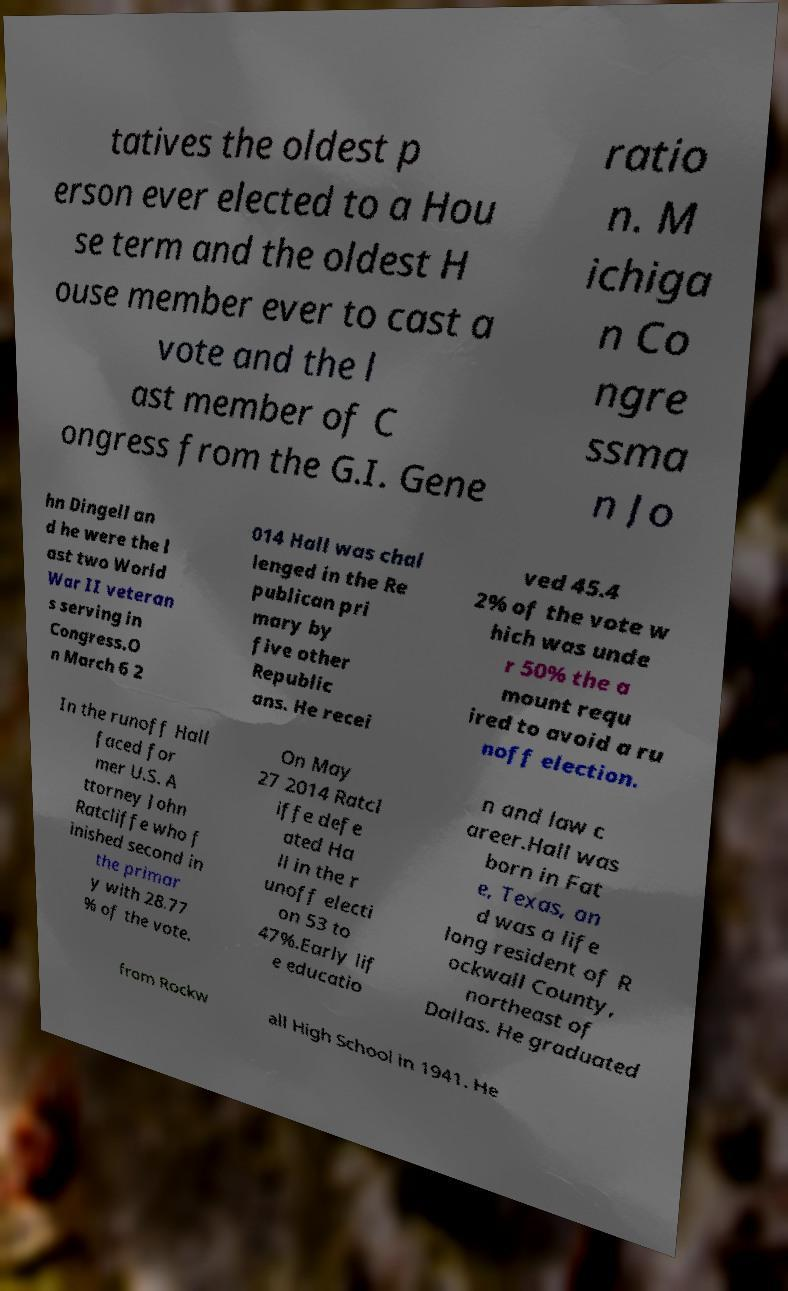What messages or text are displayed in this image? I need them in a readable, typed format. tatives the oldest p erson ever elected to a Hou se term and the oldest H ouse member ever to cast a vote and the l ast member of C ongress from the G.I. Gene ratio n. M ichiga n Co ngre ssma n Jo hn Dingell an d he were the l ast two World War II veteran s serving in Congress.O n March 6 2 014 Hall was chal lenged in the Re publican pri mary by five other Republic ans. He recei ved 45.4 2% of the vote w hich was unde r 50% the a mount requ ired to avoid a ru noff election. In the runoff Hall faced for mer U.S. A ttorney John Ratcliffe who f inished second in the primar y with 28.77 % of the vote. On May 27 2014 Ratcl iffe defe ated Ha ll in the r unoff electi on 53 to 47%.Early lif e educatio n and law c areer.Hall was born in Fat e, Texas, an d was a life long resident of R ockwall County, northeast of Dallas. He graduated from Rockw all High School in 1941. He 